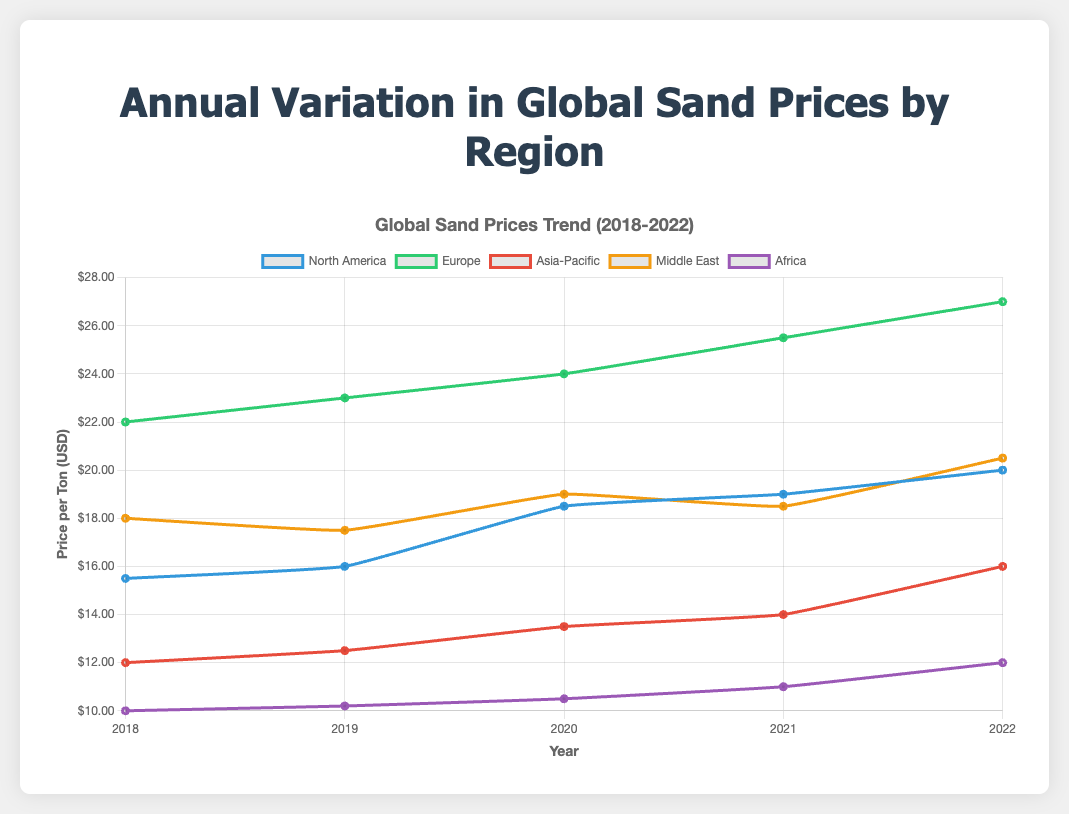What is the trend of sand prices in Europe from 2018 to 2022? The prices in Europe show a consistent upward trend each year: starting from $22.0 in 2018, rising to $23.0 in 2019, $24.0 in 2020, $25.5 in 2021, and $27.0 in 2022.
Answer: Upward trend Which region had the highest sand price per ton in 2022? By examining the plot for the year 2022, Europe had the highest price per ton at $27.0.
Answer: Europe Between North America and Asia-Pacific, which region experienced a greater percentage increase in sand prices from 2018 to 2022? North America: (20.0 - 15.5) / 15.5 * 100 = 28.98%. Asia-Pacific: (16.0 - 12.0) / 12.0 * 100 = 33.33%. Asia-Pacific experienced a greater percentage increase.
Answer: Asia-Pacific What is the difference in the price per ton between Africa and Middle East in 2021? In 2021, the price in Africa was $11.0, while in the Middle East it was $18.5. The difference is $18.5 - $11.0 = $7.5.
Answer: $7.5 How did the sand prices in the Middle East change from 2018 to 2022? The prices in the Middle East fluctuated as follows: $18.0 in 2018, $17.5 in 2019, $19.0 in 2020, $18.5 in 2021, and $20.5 in 2022. This indicates an overall increase with some fluctuations.
Answer: Fluctuated, overall increase Which region had the most stable sand prices between 2018 and 2022? Africa had the most stable prices as they experienced the smallest changes over the years: $10.0 in 2018, $10.2 in 2019, $10.5 in 2020, $11.0 in 2021, and $12.0 in 2022.
Answer: Africa What is the average sand price per ton in Asia-Pacific over the 5-year period? Adding the prices for each year and dividing by the number of years: (12.0 + 12.5 + 13.5 + 14.0 + 16.0) / 5 = 13.6.
Answer: $13.6 By how much did the price in North America increase from 2019 to 2020? The price in North America increased from $16.0 in 2019 to $18.5 in 2020. Thus, the increase was $18.5 - $16.0 = $2.5.
Answer: $2.5 Compare the sand prices in 2019 and 2020 for all regions, which region had the highest increase? Calculating the increase for each region: North America: $18.5 - $16.0 = $2.5, Europe: $24.0 - $23.0 = $1.0, Asia-Pacific: $13.5 - $12.5 = $1.0, Middle East: $19.0 - $17.5 = $1.5, Africa: $10.5 - $10.2 = $0.3. North America had the highest increase.
Answer: North America 